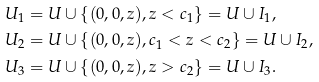<formula> <loc_0><loc_0><loc_500><loc_500>U _ { 1 } & = U \cup \{ ( 0 , 0 , z ) , z < c _ { 1 } \} = U \cup I _ { 1 } , \\ U _ { 2 } & = U \cup \{ ( 0 , 0 , z ) , c _ { 1 } < z < c _ { 2 } \} = U \cup I _ { 2 } , \\ U _ { 3 } & = U \cup \{ ( 0 , 0 , z ) , z > c _ { 2 } \} = U \cup I _ { 3 } .</formula> 